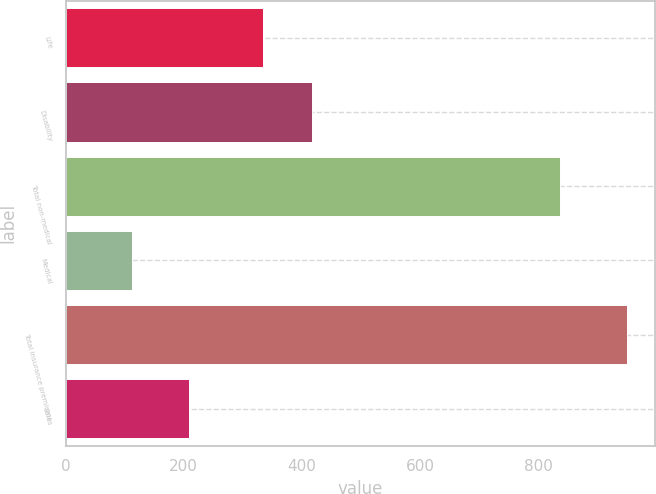Convert chart. <chart><loc_0><loc_0><loc_500><loc_500><bar_chart><fcel>Life<fcel>Disability<fcel>Total non-medical<fcel>Medical<fcel>Total insurance premiums<fcel>Sales<nl><fcel>334<fcel>417.6<fcel>836<fcel>113<fcel>949<fcel>209<nl></chart> 